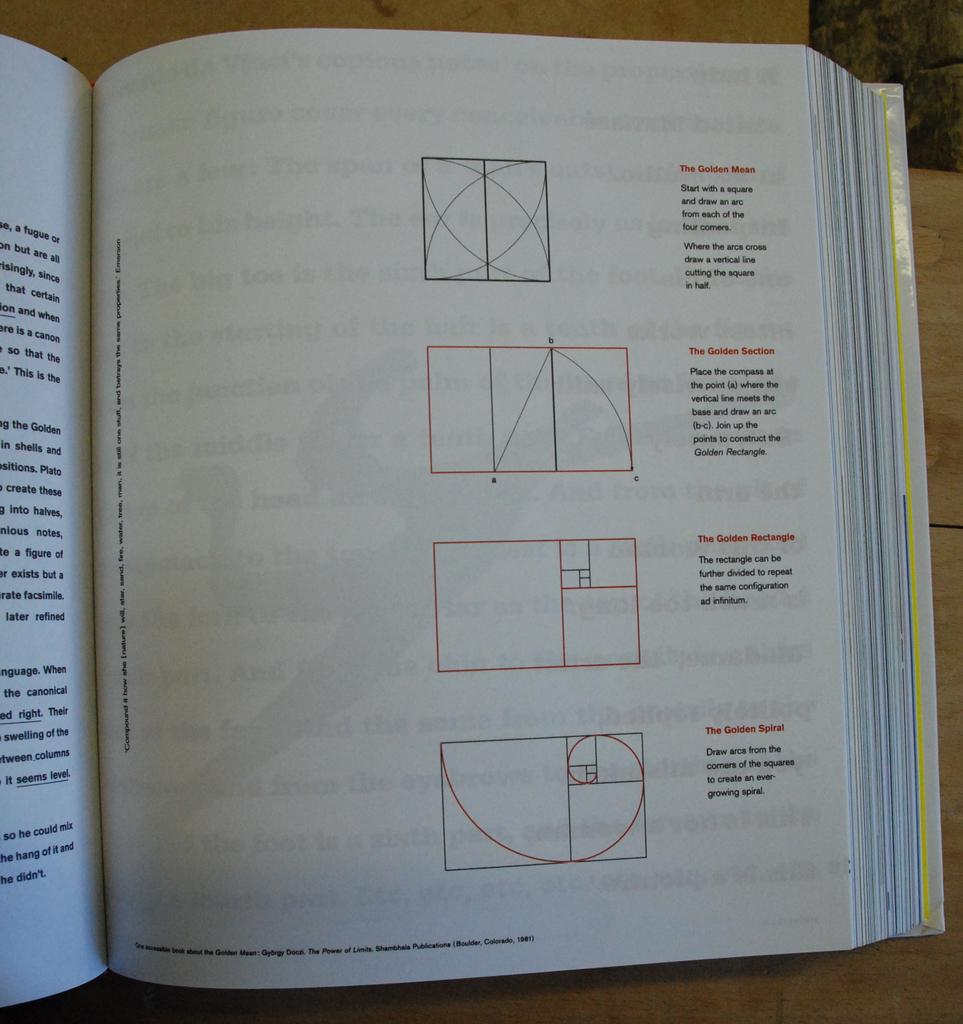<image>
Present a compact description of the photo's key features. A page from a textbook with four images and the top one is titled "the golden Mean". 